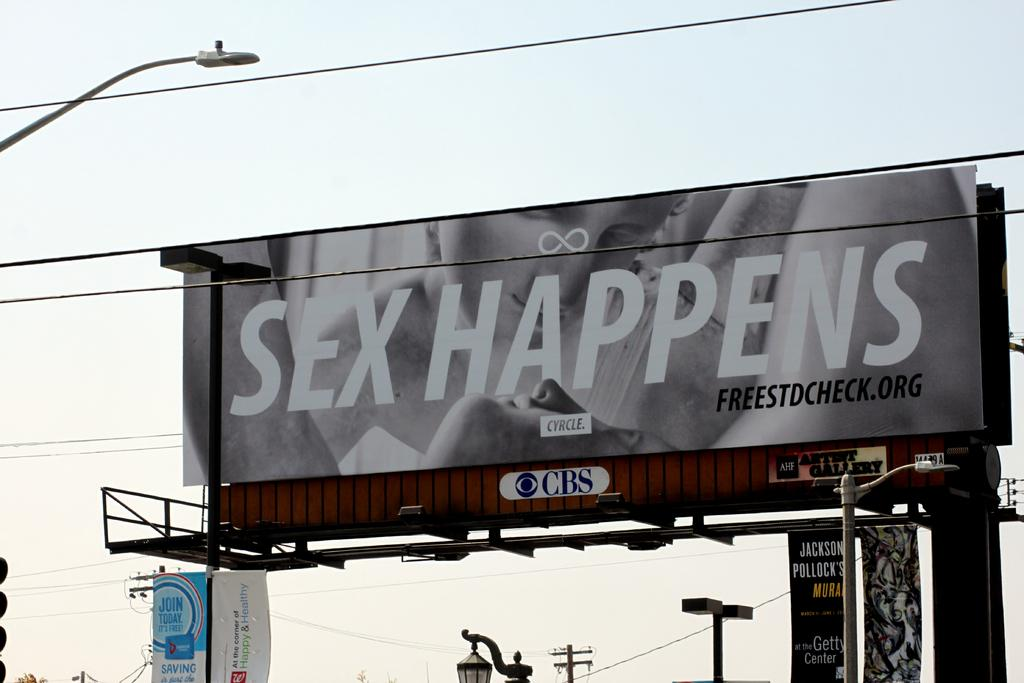Provide a one-sentence caption for the provided image. A large outdoor billboard that says Sex Happens. 